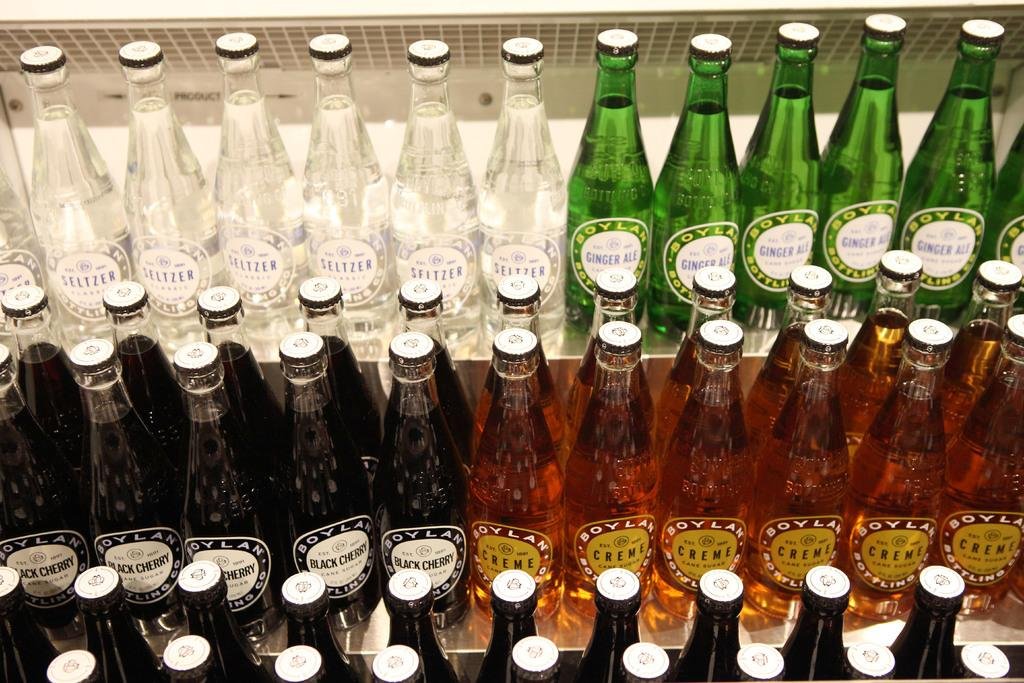<image>
Write a terse but informative summary of the picture. Green bottles of Ginger ale next to some white bottles. 